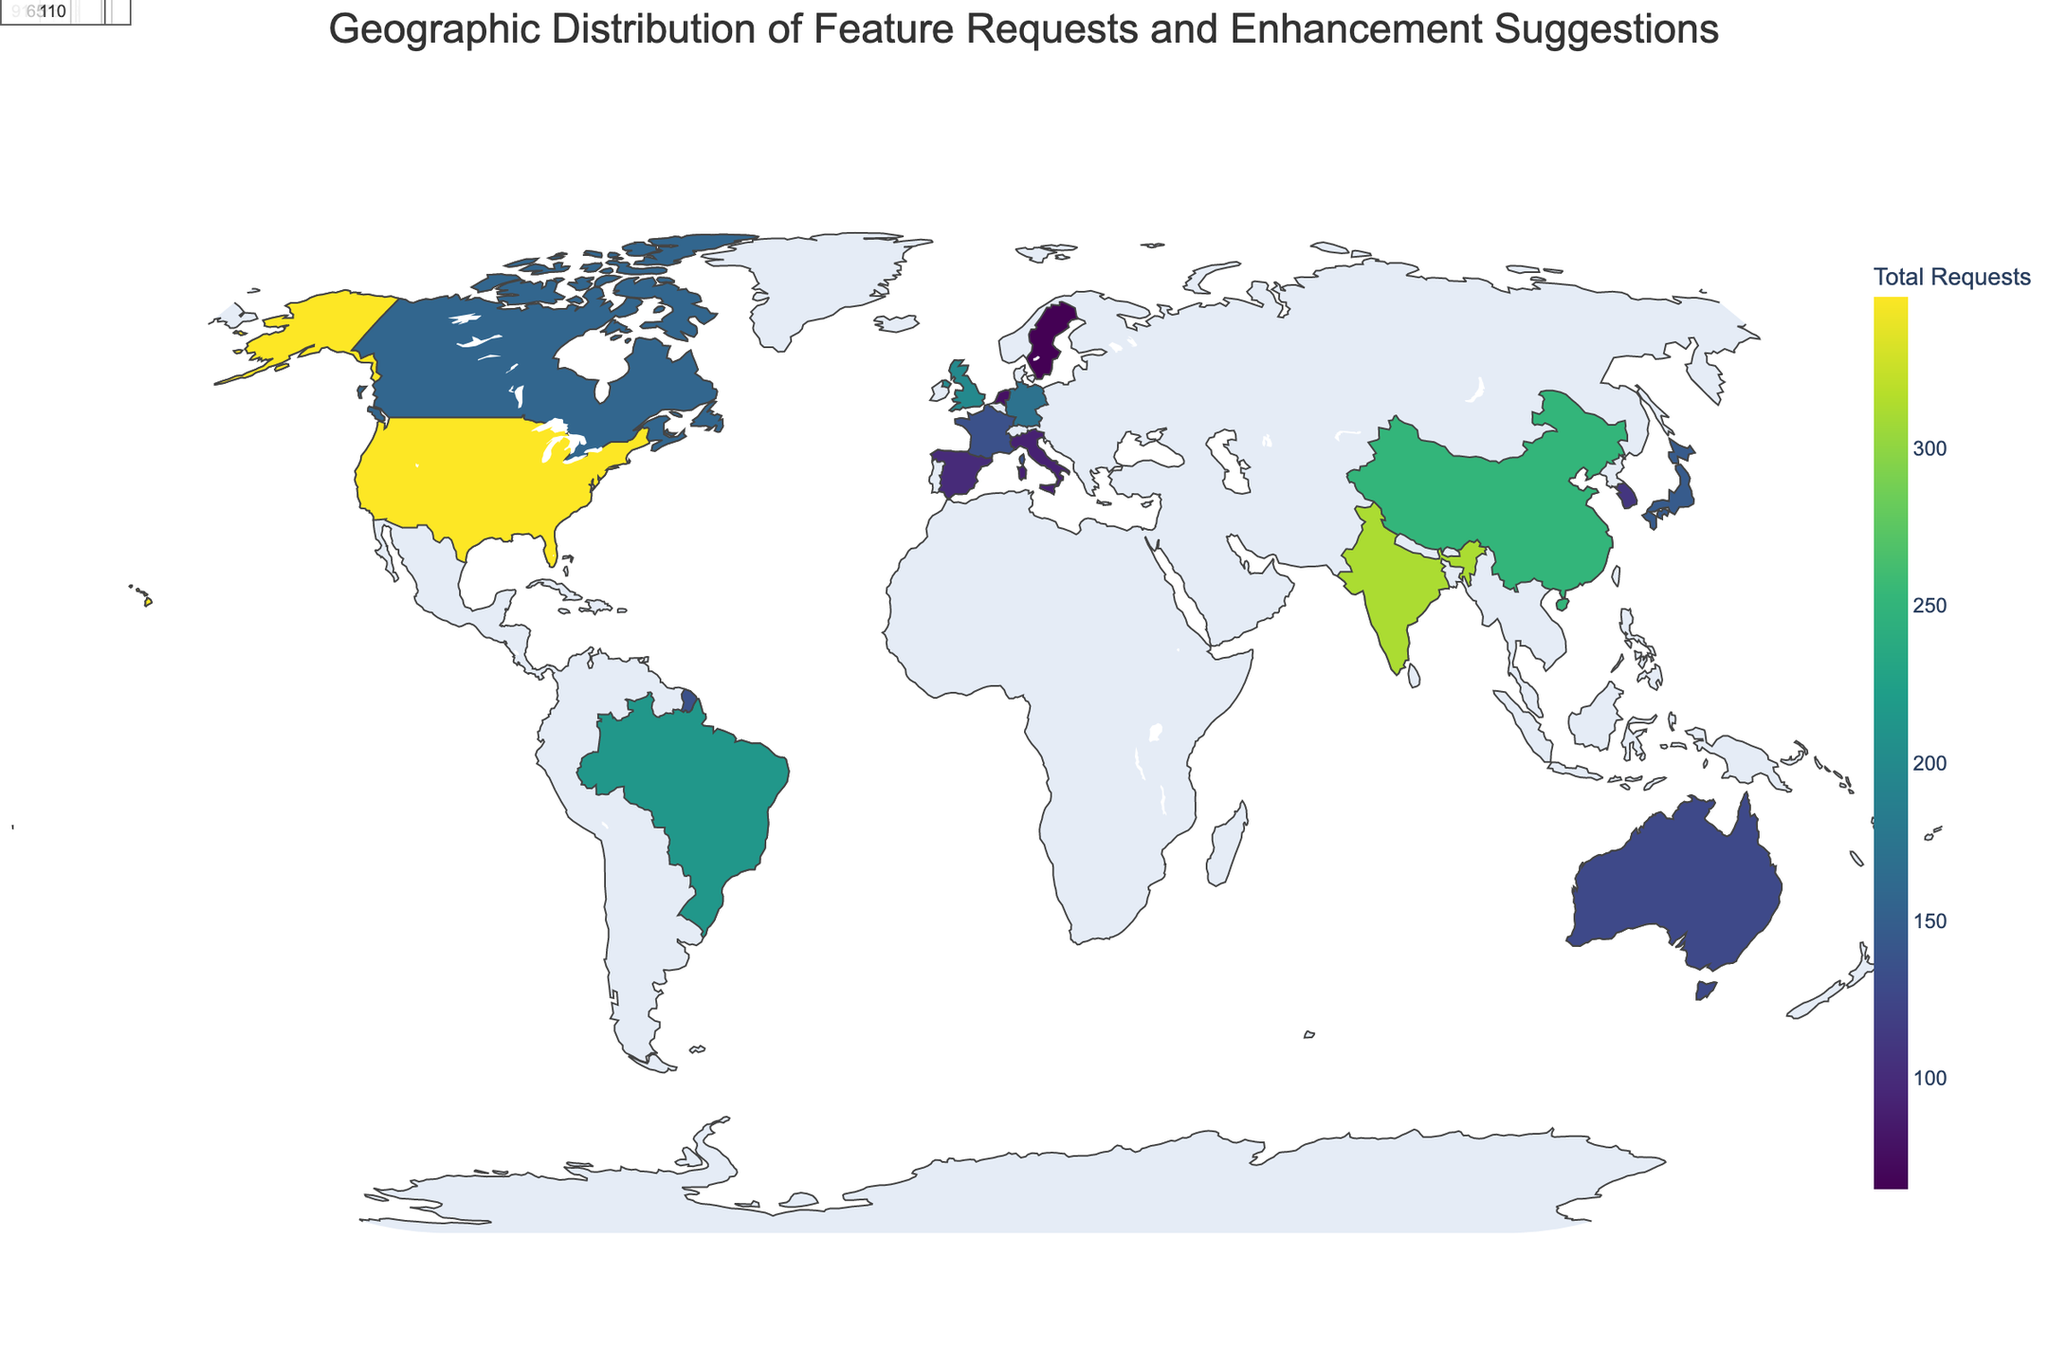What is the title of the figure? The title is usually positioned at the top of the figure. It provides an immediate understanding of what the visualization is about.
Answer: Geographic Distribution of Feature Requests and Enhancement Suggestions Which country has the highest total requests? By looking at the color intensity and annotating each country, we see which one has the highest value.
Answer: United States Compare the total requests from the United Kingdom and the Netherlands. Which country has more? Sum the feature requests and enhancement suggestions for each country. United Kingdom: 87 + 112 = 199, Netherlands: 33 + 45 = 78. The UK has more.
Answer: United Kingdom What is the sum of feature requests and enhancement suggestions from Brazil? Add the feature requests and enhancement suggestions for Brazil. 93 + 121 = 214.
Answer: 214 Which country is shown in the darkest color on the map? The country with the highest total requests will be in the darkest color, which is seen on the United States.
Answer: United States What is the color used for countries with the highest total requests? The color scale represents the range of total requests, with darker colors indicating higher values. The highest values are in dark green.
Answer: Dark green Is China's total request count higher than Japan's? Sum the counts for both countries and compare. China: 108 + 143 = 251, Japan: 62 + 84 = 146. China's count is higher.
Answer: Yes How many countries have feature requests fewer than 50? Count the number of countries with feature requests below 50 by referring to the individual data points or annotations.
Answer: 5 Which country has the smallest number of feature requests, and how many does it have? Identify the country with the lowest value in the feature requests column. The Netherlands has 33.
Answer: Netherlands, 33 Compare the number of enhancement suggestions between France and Spain. Which one has fewer? France has 77 and Spain has 58 enhancement suggestions, so Spain has fewer.
Answer: Spain 